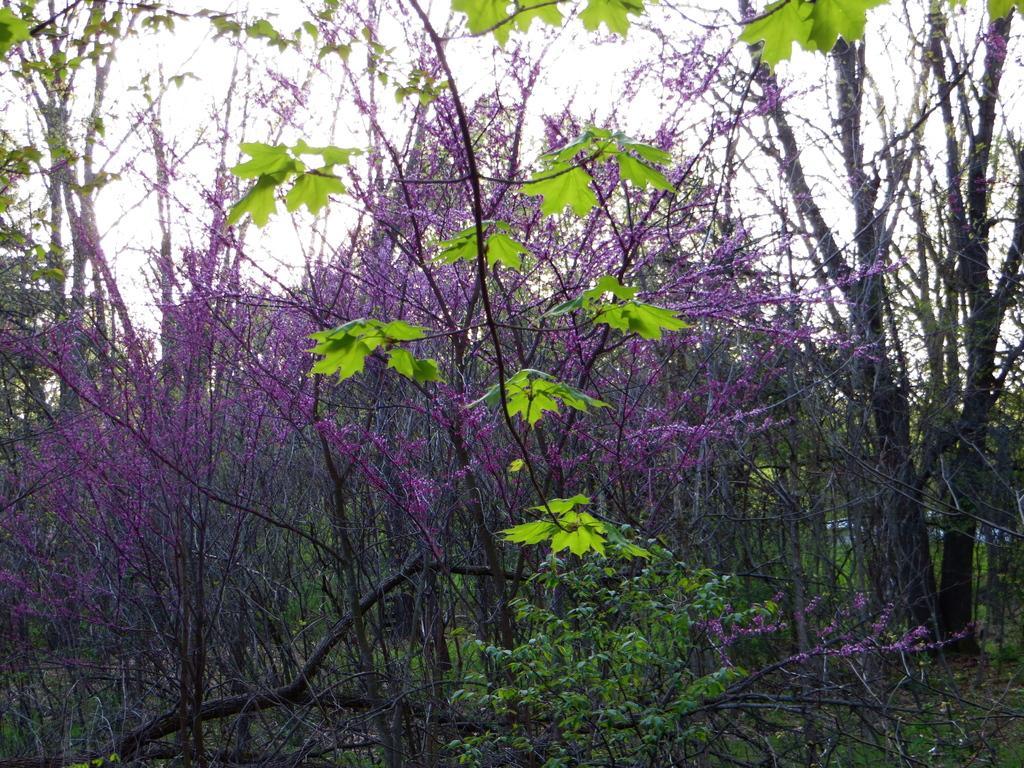How would you summarize this image in a sentence or two? As we can see in the image there are trees and grass. On the top there is sky. 